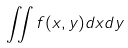<formula> <loc_0><loc_0><loc_500><loc_500>\iint f ( x , y ) d x d y</formula> 